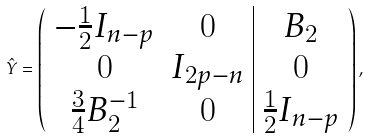<formula> <loc_0><loc_0><loc_500><loc_500>\hat { Y } = \left ( \begin{array} { c c | c } - \frac { 1 } { 2 } I _ { n - p } & 0 & B _ { 2 } \\ 0 & I _ { 2 p - n } & 0 \\ \frac { 3 } { 4 } B _ { 2 } ^ { - 1 } & 0 & \frac { 1 } { 2 } I _ { n - p } \\ \end{array} \right ) ,</formula> 